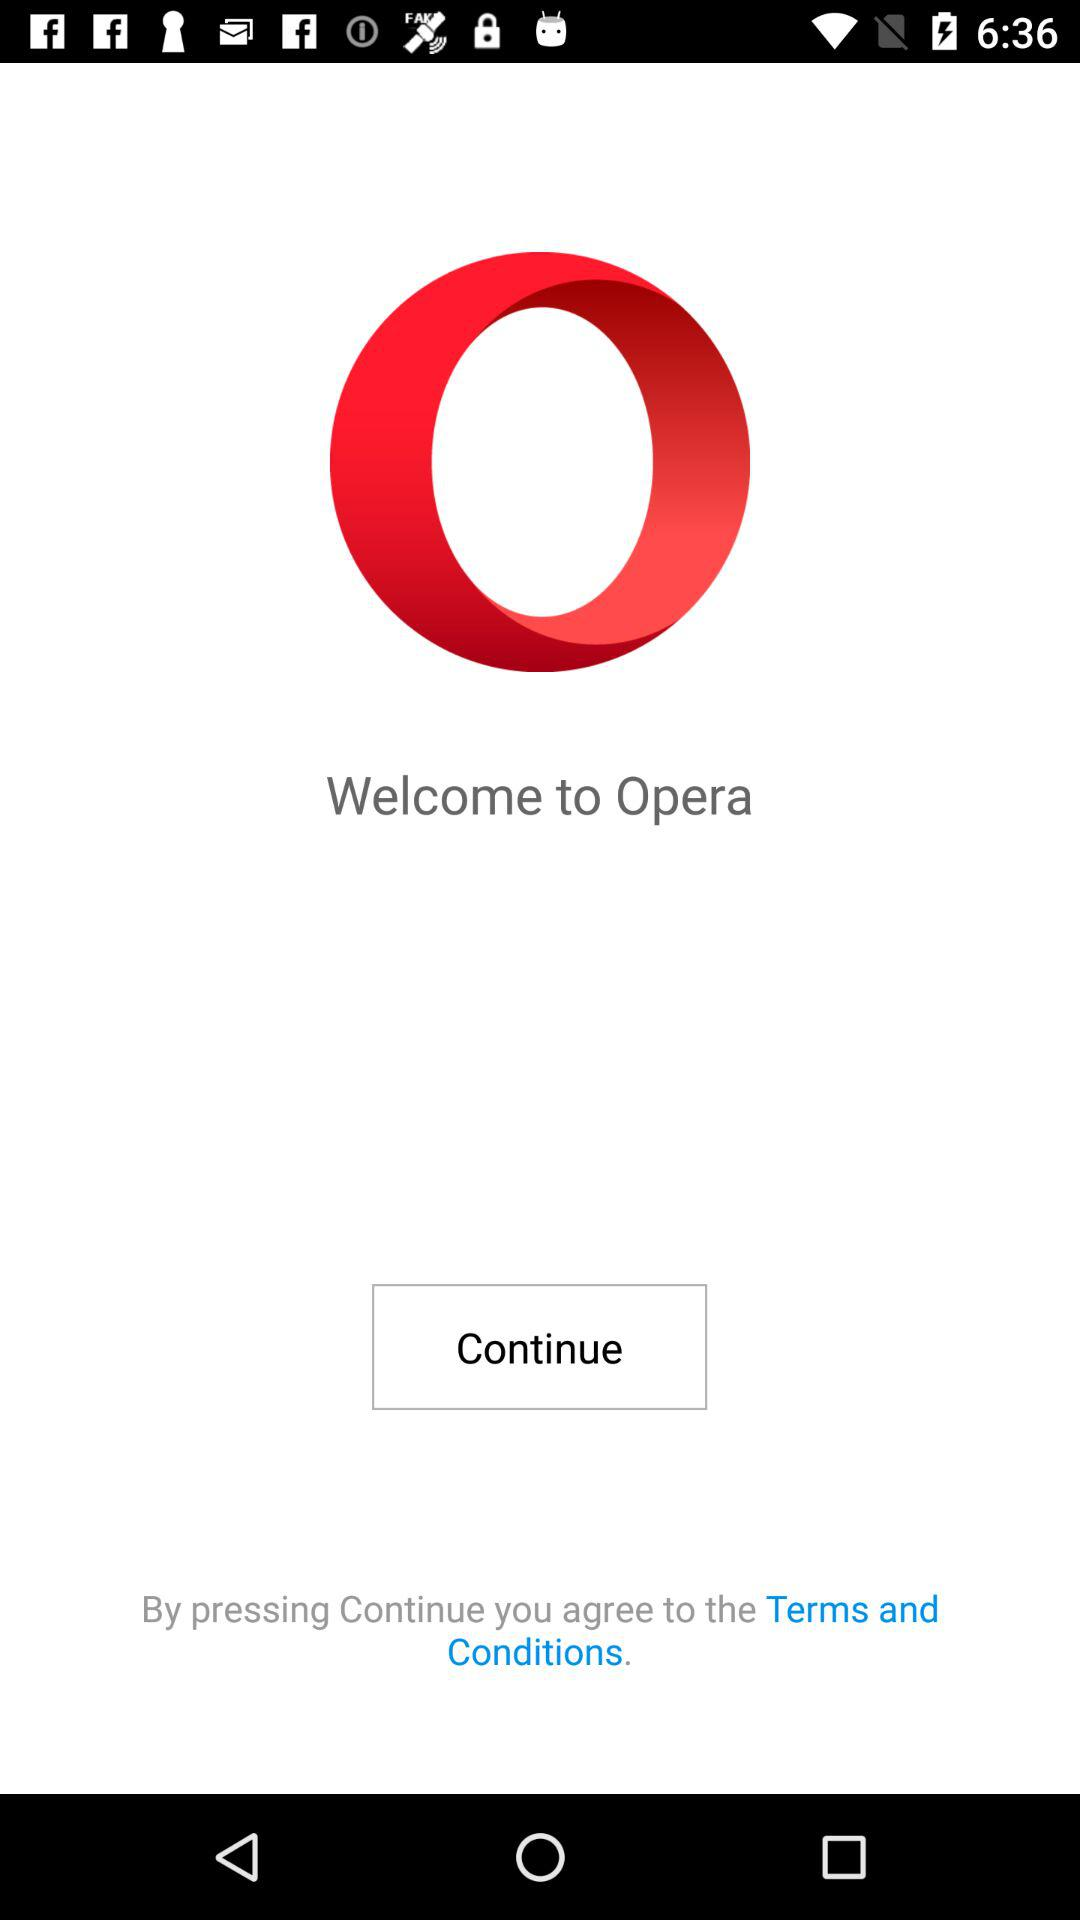What is the name of the application? The name of the application is "Opera". 